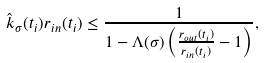<formula> <loc_0><loc_0><loc_500><loc_500>\hat { k } _ { \sigma } ( t _ { i } ) r _ { i n } ( t _ { i } ) \leq \frac { 1 } { 1 - \Lambda ( \sigma ) \left ( \frac { r _ { o u t } ( t _ { i } ) } { r _ { i n } ( t _ { i } ) } - 1 \right ) } ,</formula> 